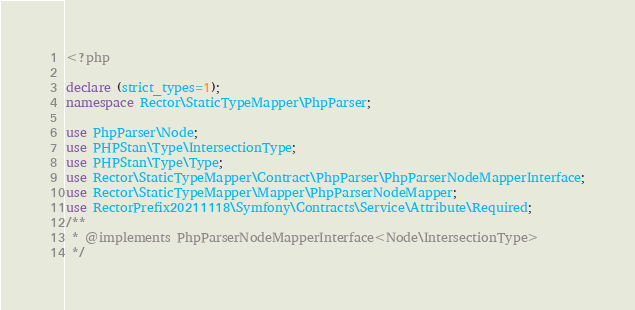Convert code to text. <code><loc_0><loc_0><loc_500><loc_500><_PHP_><?php

declare (strict_types=1);
namespace Rector\StaticTypeMapper\PhpParser;

use PhpParser\Node;
use PHPStan\Type\IntersectionType;
use PHPStan\Type\Type;
use Rector\StaticTypeMapper\Contract\PhpParser\PhpParserNodeMapperInterface;
use Rector\StaticTypeMapper\Mapper\PhpParserNodeMapper;
use RectorPrefix20211118\Symfony\Contracts\Service\Attribute\Required;
/**
 * @implements PhpParserNodeMapperInterface<Node\IntersectionType>
 */</code> 